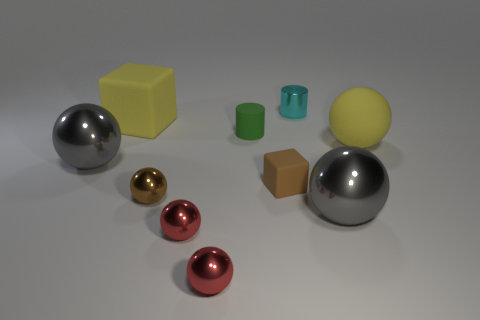How many matte cubes are the same color as the big matte sphere?
Give a very brief answer. 1. Is the number of big gray metal things that are on the left side of the tiny green thing the same as the number of gray matte balls?
Give a very brief answer. No. Is there a big metal ball that is to the left of the yellow object that is to the left of the large gray ball to the right of the small cyan thing?
Provide a short and direct response. Yes. The big cube that is made of the same material as the green cylinder is what color?
Offer a terse response. Yellow. There is a large metallic sphere that is in front of the brown sphere; is its color the same as the big matte ball?
Your answer should be very brief. No. How many balls are small rubber objects or tiny blue rubber objects?
Your answer should be very brief. 0. There is a brown metallic object right of the large metal ball that is to the left of the large yellow matte object that is to the left of the tiny block; what size is it?
Your response must be concise. Small. What shape is the green rubber thing that is the same size as the brown rubber cube?
Give a very brief answer. Cylinder. There is a brown metal thing; what shape is it?
Keep it short and to the point. Sphere. Is the yellow thing that is left of the tiny brown matte thing made of the same material as the yellow ball?
Your answer should be compact. Yes. 